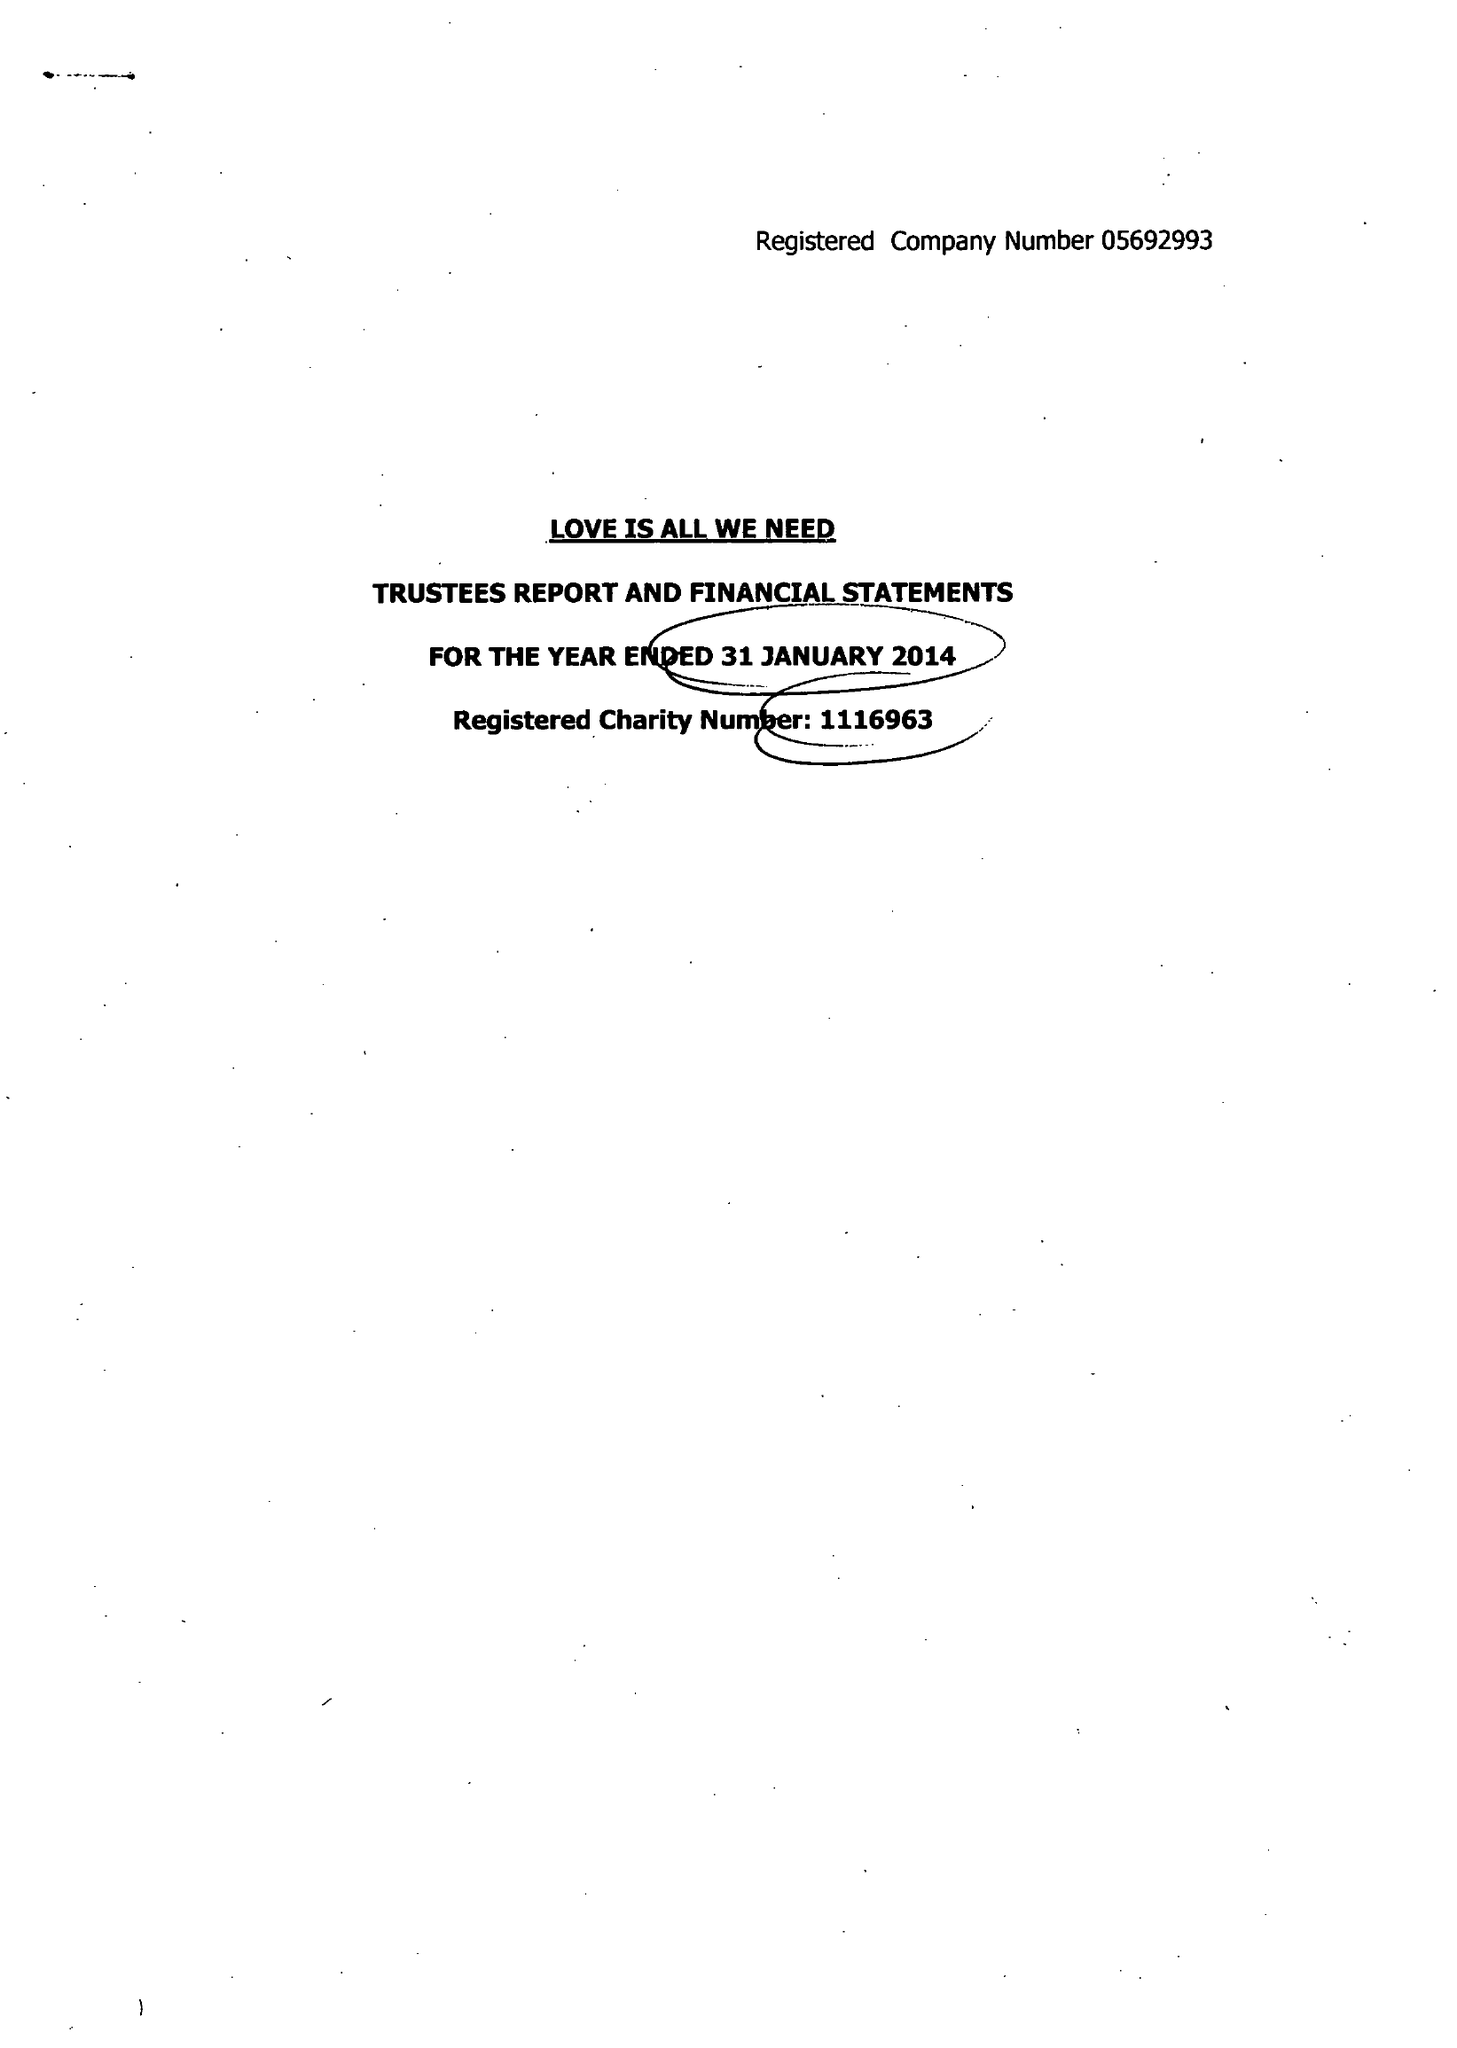What is the value for the address__street_line?
Answer the question using a single word or phrase. 43 WALSINGHAM ROAD 